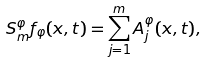Convert formula to latex. <formula><loc_0><loc_0><loc_500><loc_500>S ^ { \varphi } _ { m } f _ { \varphi } ( x , t ) = \sum _ { j = 1 } ^ { m } A ^ { \varphi } _ { j } ( x , t ) ,</formula> 